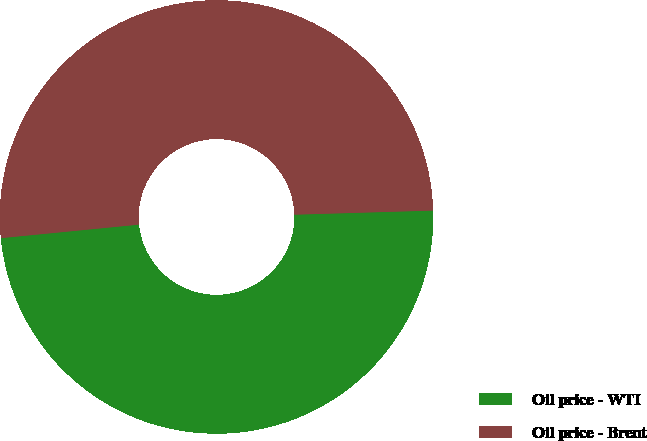<chart> <loc_0><loc_0><loc_500><loc_500><pie_chart><fcel>Oil price - WTI<fcel>Oil price - Brent<nl><fcel>48.92%<fcel>51.08%<nl></chart> 